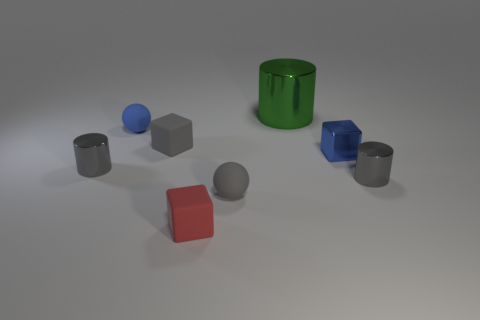Subtract all gray cylinders. How many cylinders are left? 1 Subtract all cyan spheres. How many gray cylinders are left? 2 Subtract 1 blocks. How many blocks are left? 2 Subtract all balls. How many objects are left? 6 Add 2 blue spheres. How many objects exist? 10 Subtract all gray balls. How many balls are left? 1 Subtract all yellow blocks. Subtract all red spheres. How many blocks are left? 3 Subtract 2 gray cylinders. How many objects are left? 6 Subtract all blocks. Subtract all big metallic cylinders. How many objects are left? 4 Add 6 tiny metal cylinders. How many tiny metal cylinders are left? 8 